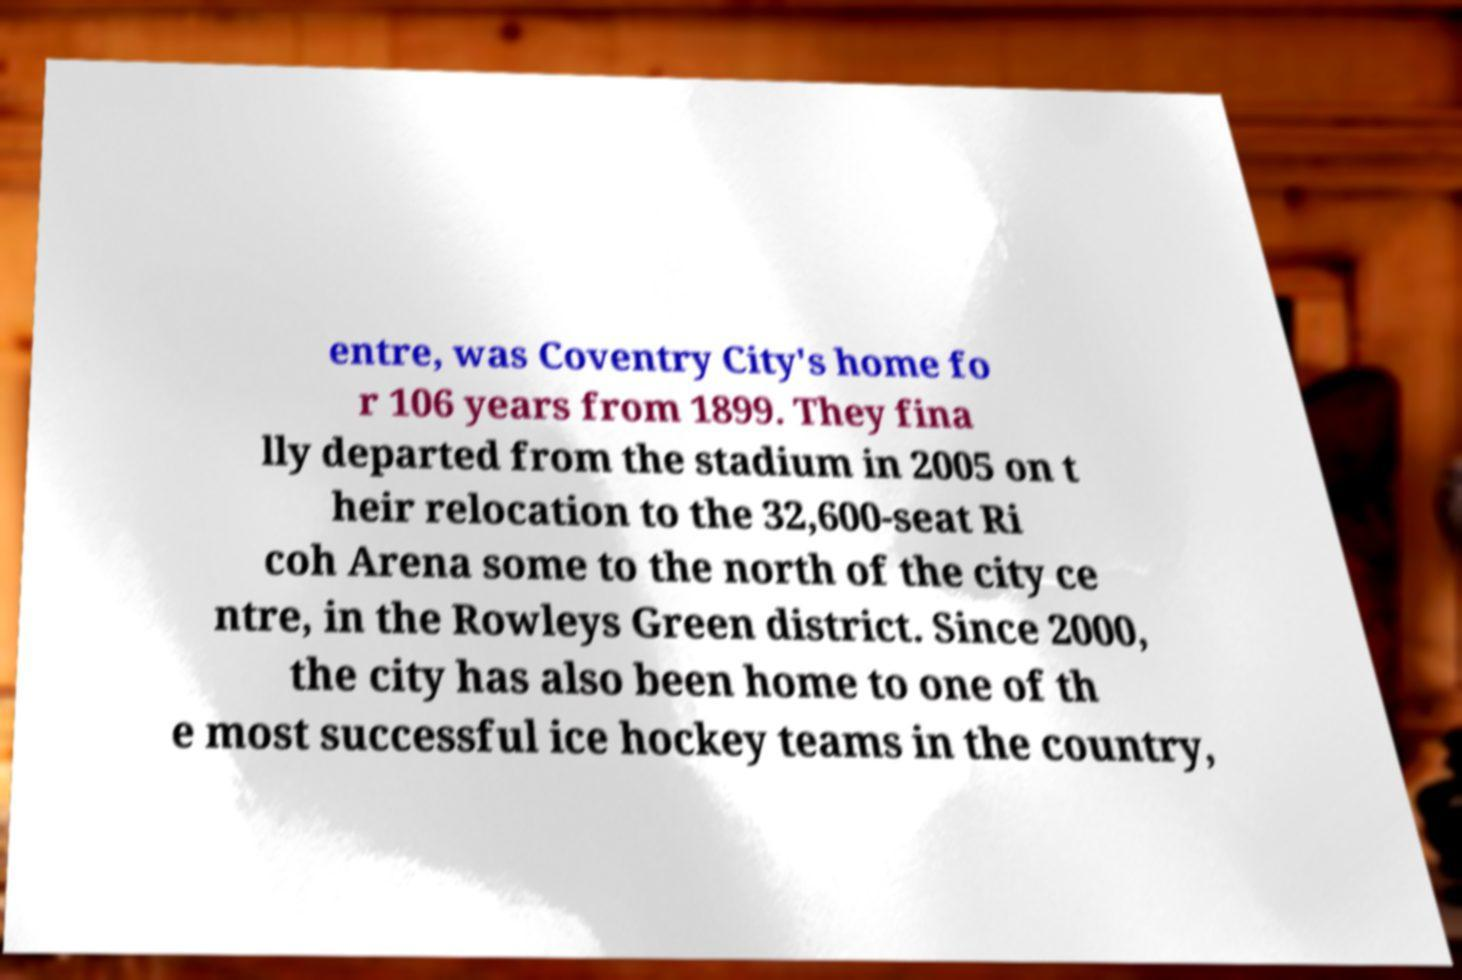Can you read and provide the text displayed in the image?This photo seems to have some interesting text. Can you extract and type it out for me? entre, was Coventry City's home fo r 106 years from 1899. They fina lly departed from the stadium in 2005 on t heir relocation to the 32,600-seat Ri coh Arena some to the north of the city ce ntre, in the Rowleys Green district. Since 2000, the city has also been home to one of th e most successful ice hockey teams in the country, 